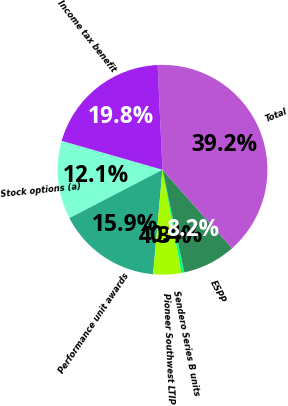Convert chart. <chart><loc_0><loc_0><loc_500><loc_500><pie_chart><fcel>Stock options (a)<fcel>Performance unit awards<fcel>Pioneer Southwest LTIP<fcel>Sendero Series B units<fcel>ESPP<fcel>Total<fcel>Income tax benefit<nl><fcel>12.07%<fcel>15.95%<fcel>4.32%<fcel>0.45%<fcel>8.2%<fcel>39.2%<fcel>19.82%<nl></chart> 